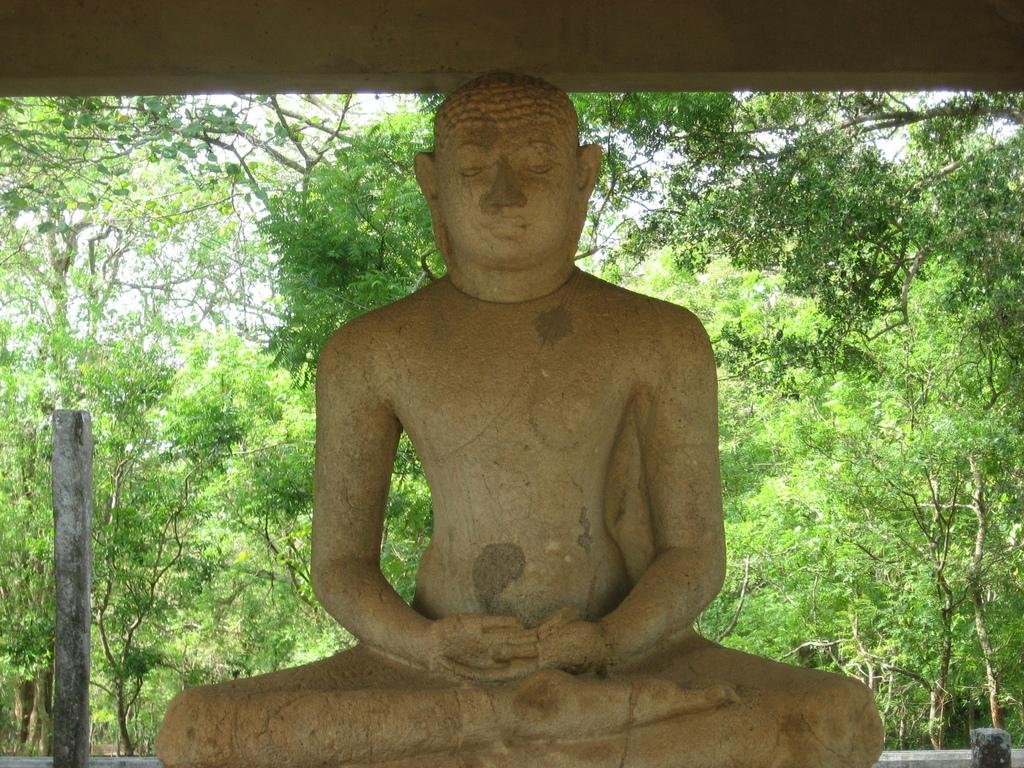What is the main subject of the image? There is a sculpture of a person in the image. What can be seen in the background of the image? There are trees in the background of the image. What architectural feature is present on the left side of the image? There is a pillar on the left side of the image. What level of expertise does the sculpture have in using a pencil in the image? There is no indication of the sculpture's skill level with a pencil, as it is a sculpture and not a person. 